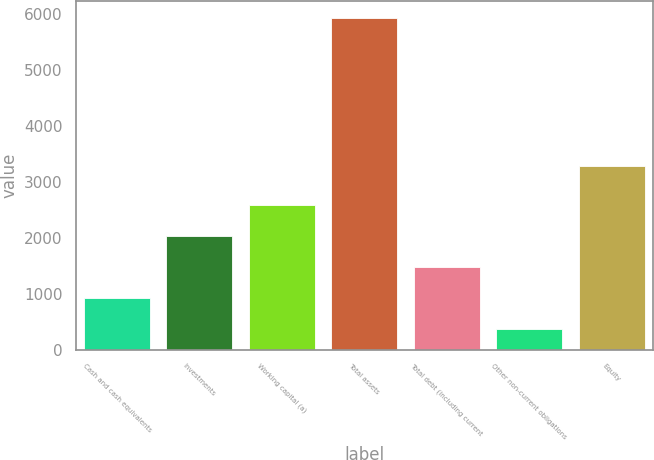Convert chart to OTSL. <chart><loc_0><loc_0><loc_500><loc_500><bar_chart><fcel>Cash and cash equivalents<fcel>Investments<fcel>Working capital (a)<fcel>Total assets<fcel>Total debt (including current<fcel>Other non-current obligations<fcel>Equity<nl><fcel>917.65<fcel>2034.35<fcel>2592.7<fcel>5942.8<fcel>1476<fcel>359.3<fcel>3287.2<nl></chart> 